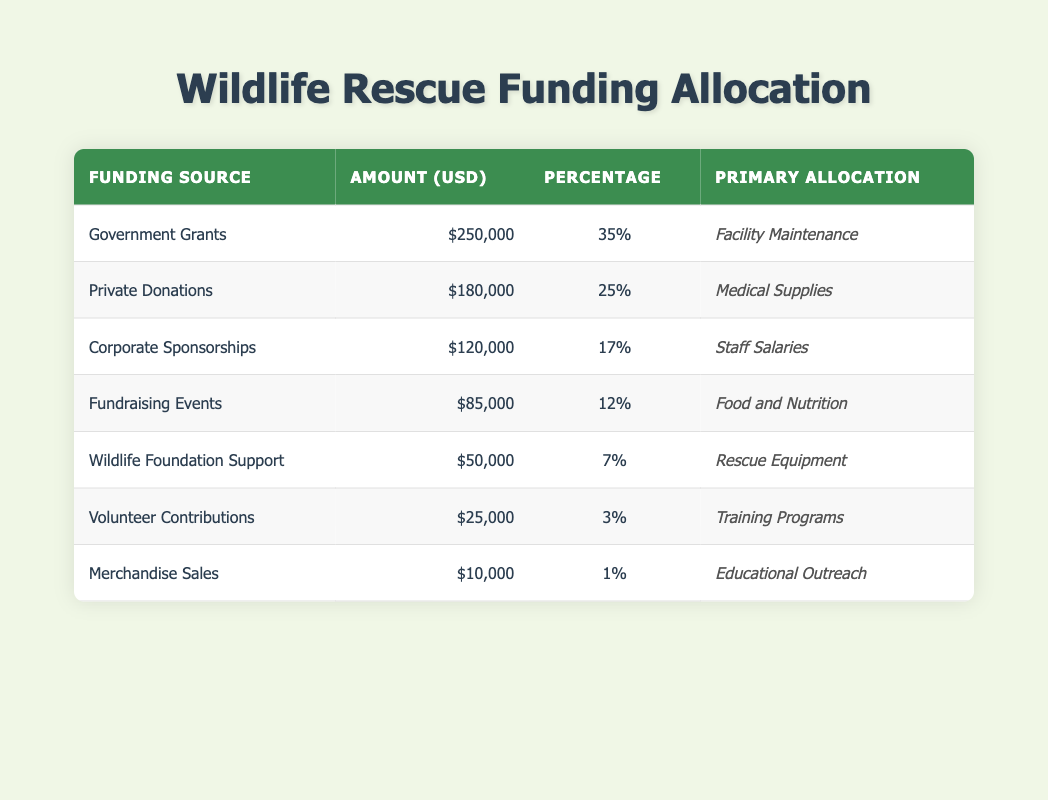What is the total amount of funding from Government Grants? The amount listed in the table for Government Grants is 250000 USD.
Answer: 250000 USD Which funding source has the highest percentage allocation? Government Grants, with a percentage allocation of 35%, is the highest in the table.
Answer: Government Grants What is the primary allocation for Private Donations? The table shows that Private Donations are primarily allocated for Medical Supplies.
Answer: Medical Supplies If we add the amounts from Corporate Sponsorships and Fundraising Events, what is the total? The amount from Corporate Sponsorships is 120000 USD, and from Fundraising Events is 85000 USD. Adding these gives 120000 + 85000 = 205000 USD.
Answer: 205000 USD Are Volunteer Contributions more or less than 5% of the total funding? Volunteer Contributions are listed as 3%, which is less than 5%.
Answer: Less than 5% What is the percentage of funding allocation for Wildlife Foundation Support? The table indicates that the percentage of funding allocation for Wildlife Foundation Support is 7%.
Answer: 7% What is the combined amount of the top three funding sources? The top three funding sources are Government Grants (250000 USD), Private Donations (180000 USD), and Corporate Sponsorships (120000 USD). Their combined amount is 250000 + 180000 + 120000 = 550000 USD.
Answer: 550000 USD Is the amount allocated for Educational Outreach more or less than 20000 USD? The amount for Educational Outreach is 10000 USD, which is less than 20000 USD.
Answer: Less than 20000 USD How much funding is allocated to Food and Nutrition compared to medical supplies? The amount for Food and Nutrition is 85000 USD, while for Medical Supplies, it is 180000 USD. Therefore, 85000 is less than 180000.
Answer: Food and Nutrition is less than Medical Supplies 